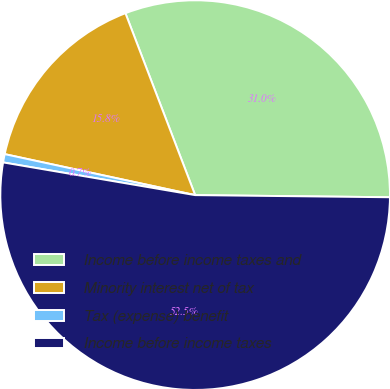<chart> <loc_0><loc_0><loc_500><loc_500><pie_chart><fcel>Income before income taxes and<fcel>Minority interest net of tax<fcel>Tax (expense) benefit<fcel>Income before income taxes<nl><fcel>31.0%<fcel>15.8%<fcel>0.69%<fcel>52.51%<nl></chart> 